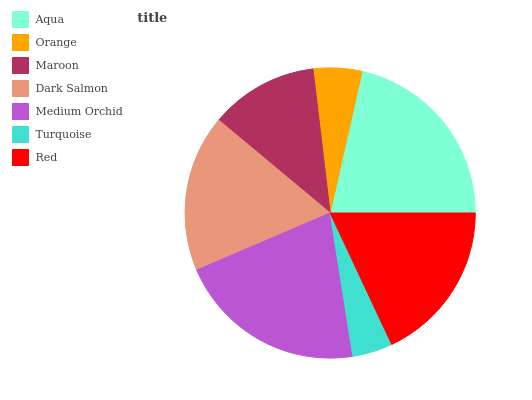Is Turquoise the minimum?
Answer yes or no. Yes. Is Aqua the maximum?
Answer yes or no. Yes. Is Orange the minimum?
Answer yes or no. No. Is Orange the maximum?
Answer yes or no. No. Is Aqua greater than Orange?
Answer yes or no. Yes. Is Orange less than Aqua?
Answer yes or no. Yes. Is Orange greater than Aqua?
Answer yes or no. No. Is Aqua less than Orange?
Answer yes or no. No. Is Dark Salmon the high median?
Answer yes or no. Yes. Is Dark Salmon the low median?
Answer yes or no. Yes. Is Aqua the high median?
Answer yes or no. No. Is Turquoise the low median?
Answer yes or no. No. 